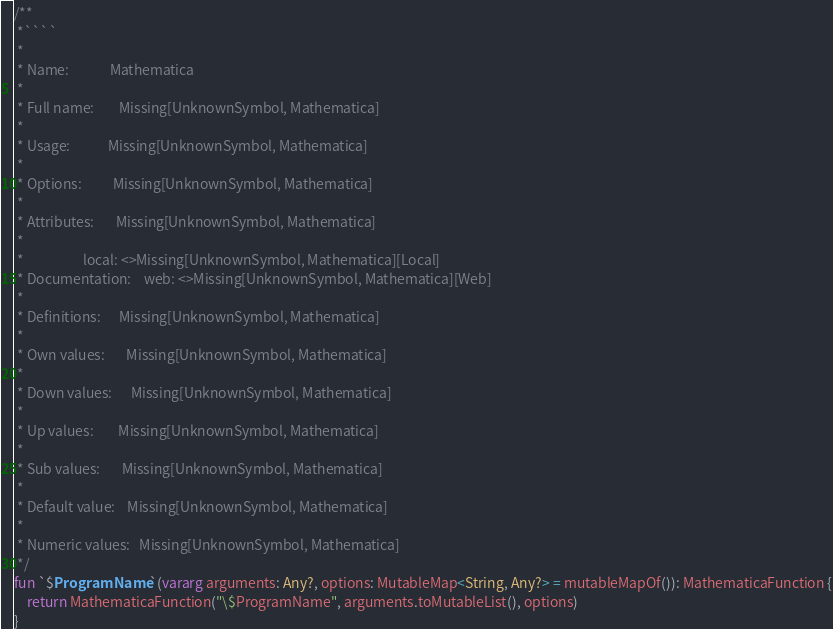Convert code to text. <code><loc_0><loc_0><loc_500><loc_500><_Kotlin_>
/**
 *````
 *
 * Name:             Mathematica
 *
 * Full name:        Missing[UnknownSymbol, Mathematica]
 *
 * Usage:            Missing[UnknownSymbol, Mathematica]
 *
 * Options:          Missing[UnknownSymbol, Mathematica]
 *
 * Attributes:       Missing[UnknownSymbol, Mathematica]
 *
 *                   local: <>Missing[UnknownSymbol, Mathematica][Local]
 * Documentation:    web: <>Missing[UnknownSymbol, Mathematica][Web]
 *
 * Definitions:      Missing[UnknownSymbol, Mathematica]
 *
 * Own values:       Missing[UnknownSymbol, Mathematica]
 *
 * Down values:      Missing[UnknownSymbol, Mathematica]
 *
 * Up values:        Missing[UnknownSymbol, Mathematica]
 *
 * Sub values:       Missing[UnknownSymbol, Mathematica]
 *
 * Default value:    Missing[UnknownSymbol, Mathematica]
 *
 * Numeric values:   Missing[UnknownSymbol, Mathematica]
 */
fun `$ProgramName`(vararg arguments: Any?, options: MutableMap<String, Any?> = mutableMapOf()): MathematicaFunction {
	return MathematicaFunction("\$ProgramName", arguments.toMutableList(), options)
}
</code> 